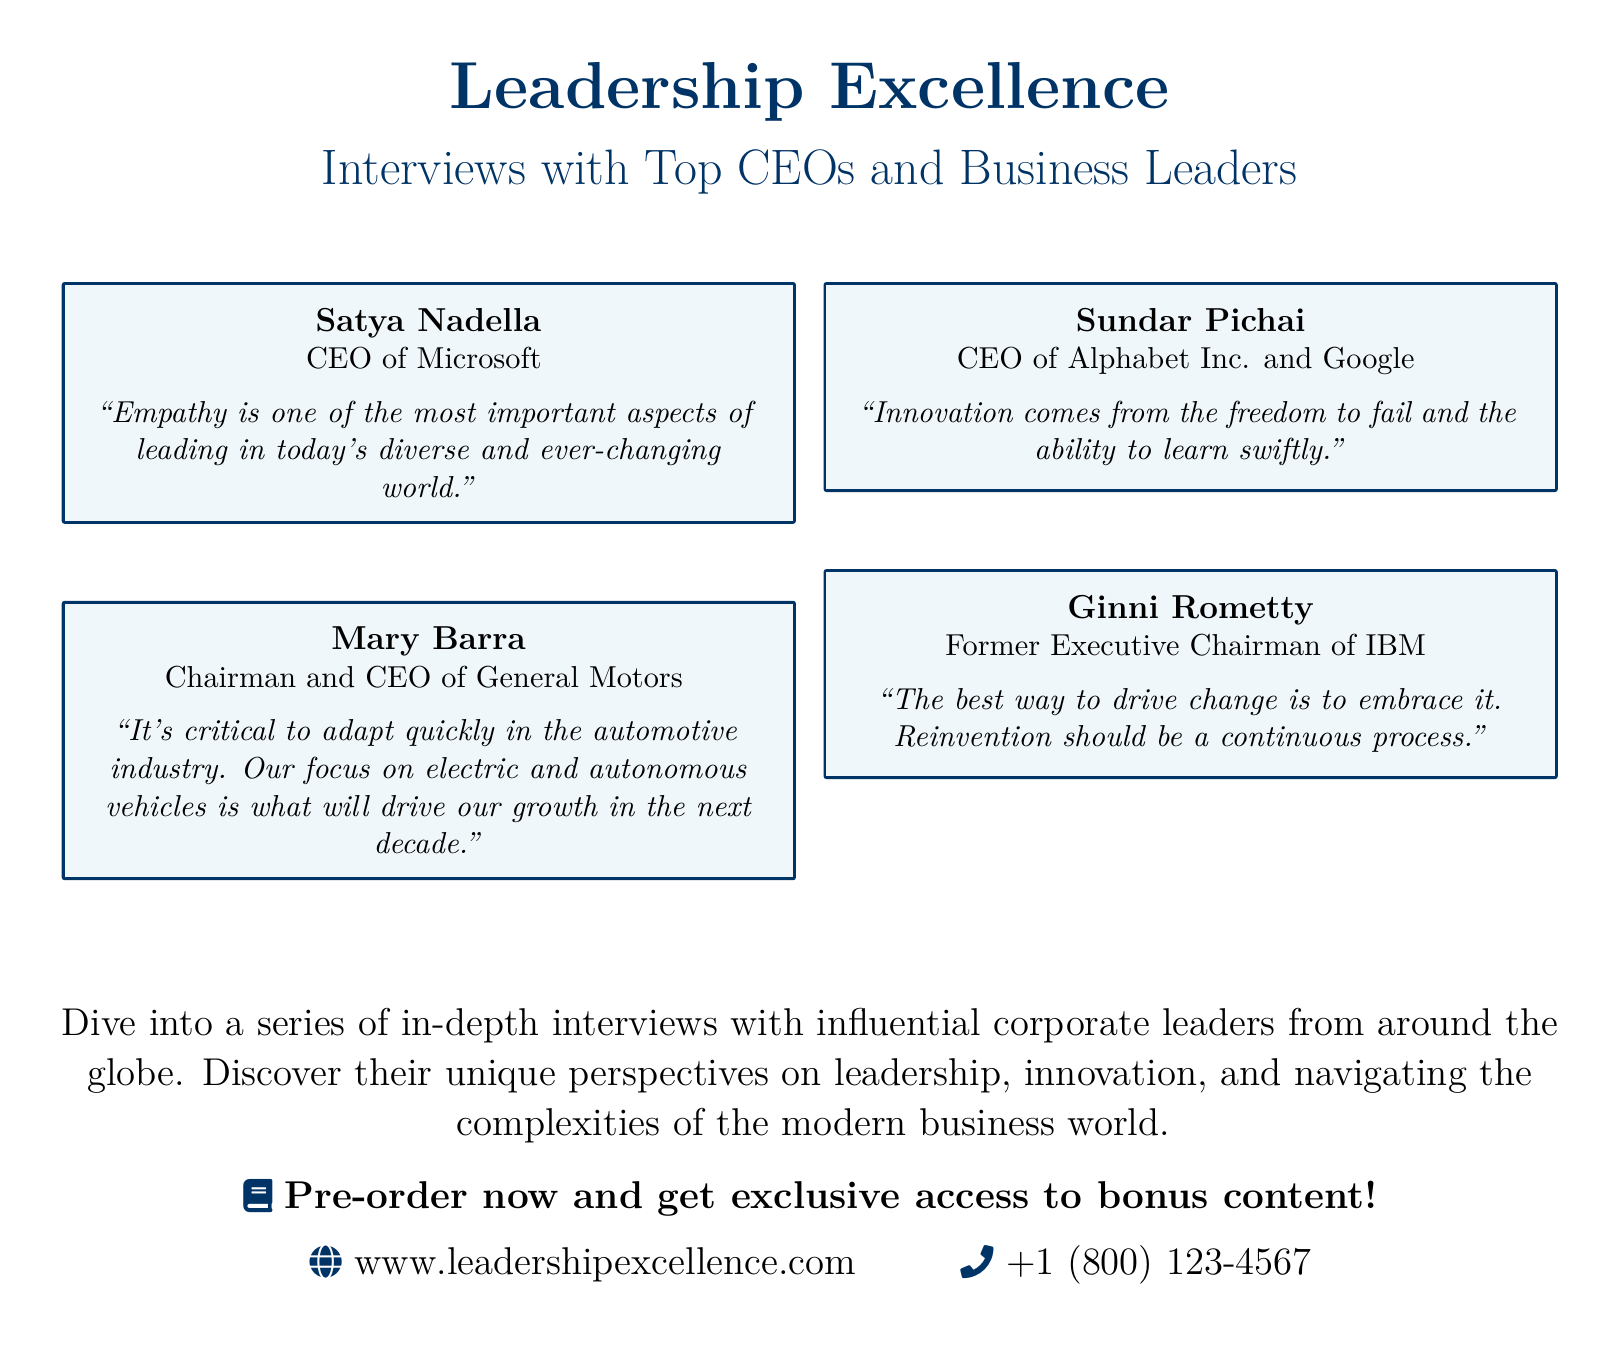What is the title of the document? The title is prominently displayed at the top of the document.
Answer: Leadership Excellence Who is the CEO of Microsoft featured in the document? The document specifically mentions corporate leaders, including their titles and names.
Answer: Satya Nadella What is the focus of Mary Barra's leadership strategy? The quote highlights her emphasis on a specific industry focus.
Answer: Electric and autonomous vehicles Which corporate leader discussed the importance of innovation? The document includes insights from various leaders with specific quotes about leadership themes.
Answer: Sundar Pichai What is the website listed for Leadership Excellence? The URL is prominently shown towards the end of the document.
Answer: www.leadershipexcellence.com How many corporate leaders are featured in the document? The document clearly lists four distinct leaders with their quotes.
Answer: Four What is Ginni Rometty's perspective on change? The quote provides insight into her views on leadership and transformation.
Answer: Embrace it What type of content can pre-order customers expect? The document offers an incentive for pre-orders that includes additional content.
Answer: Exclusive access to bonus content What is the phone number provided in the document? The document shares a contact phone number towards the end.
Answer: +1 (800) 123-4567 